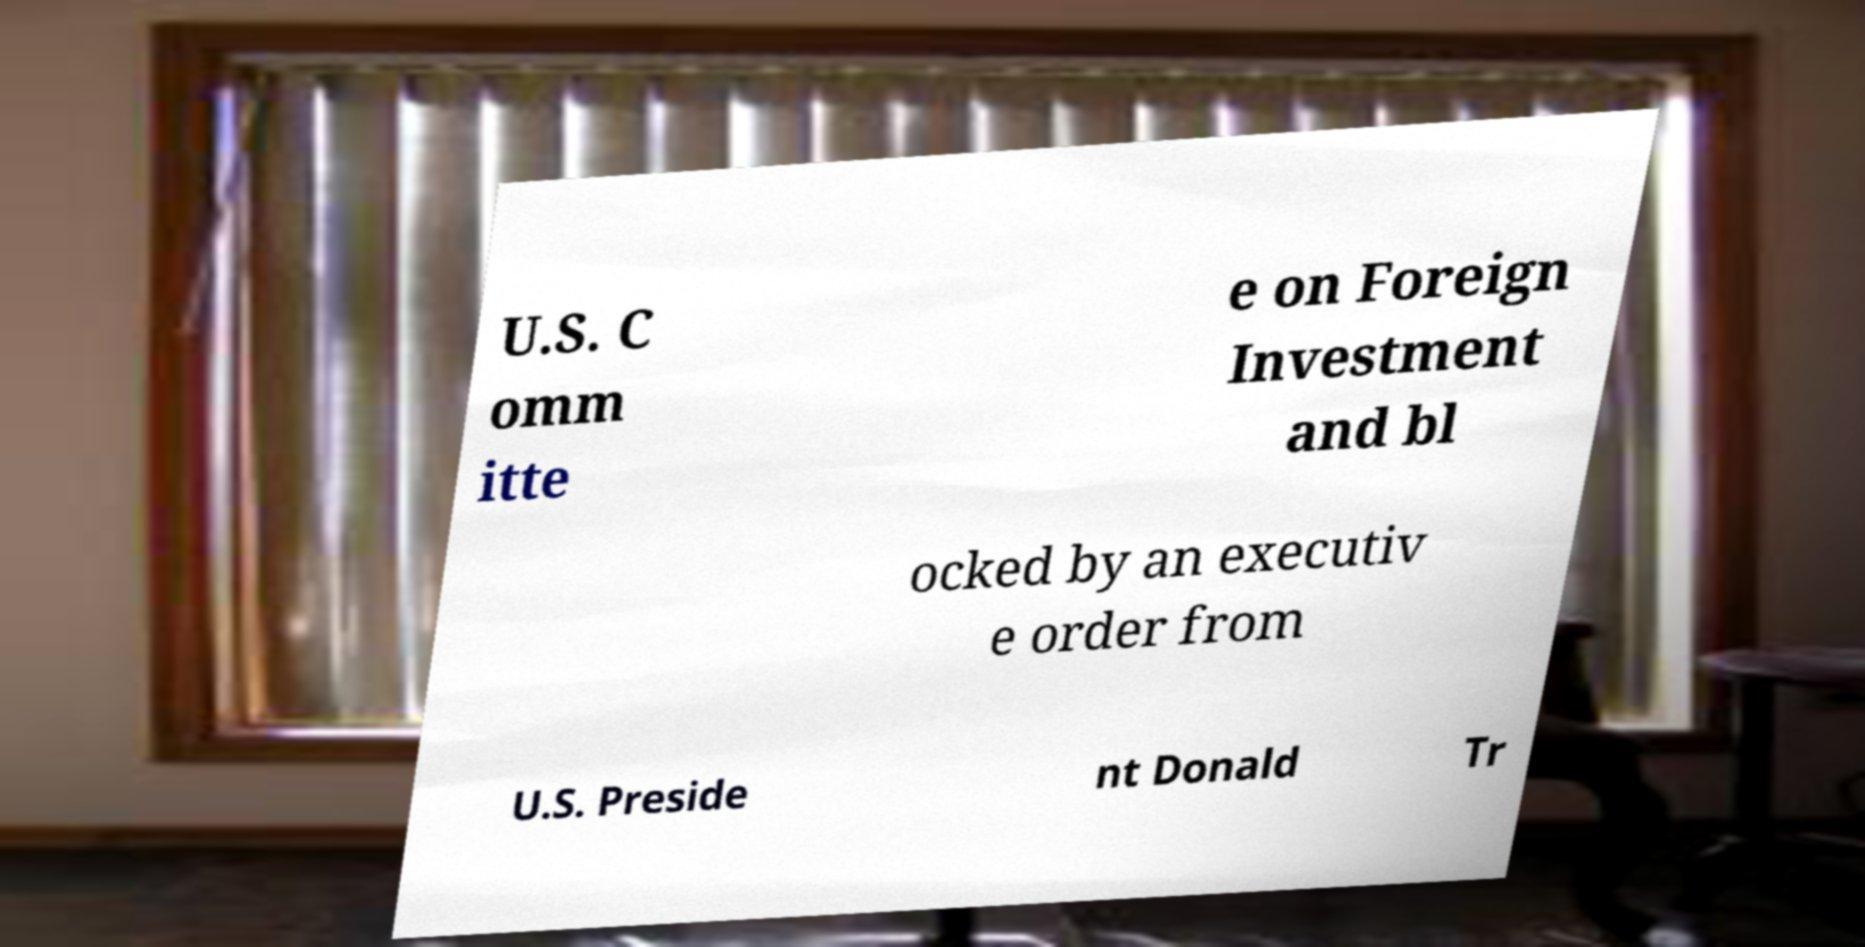Can you accurately transcribe the text from the provided image for me? U.S. C omm itte e on Foreign Investment and bl ocked by an executiv e order from U.S. Preside nt Donald Tr 